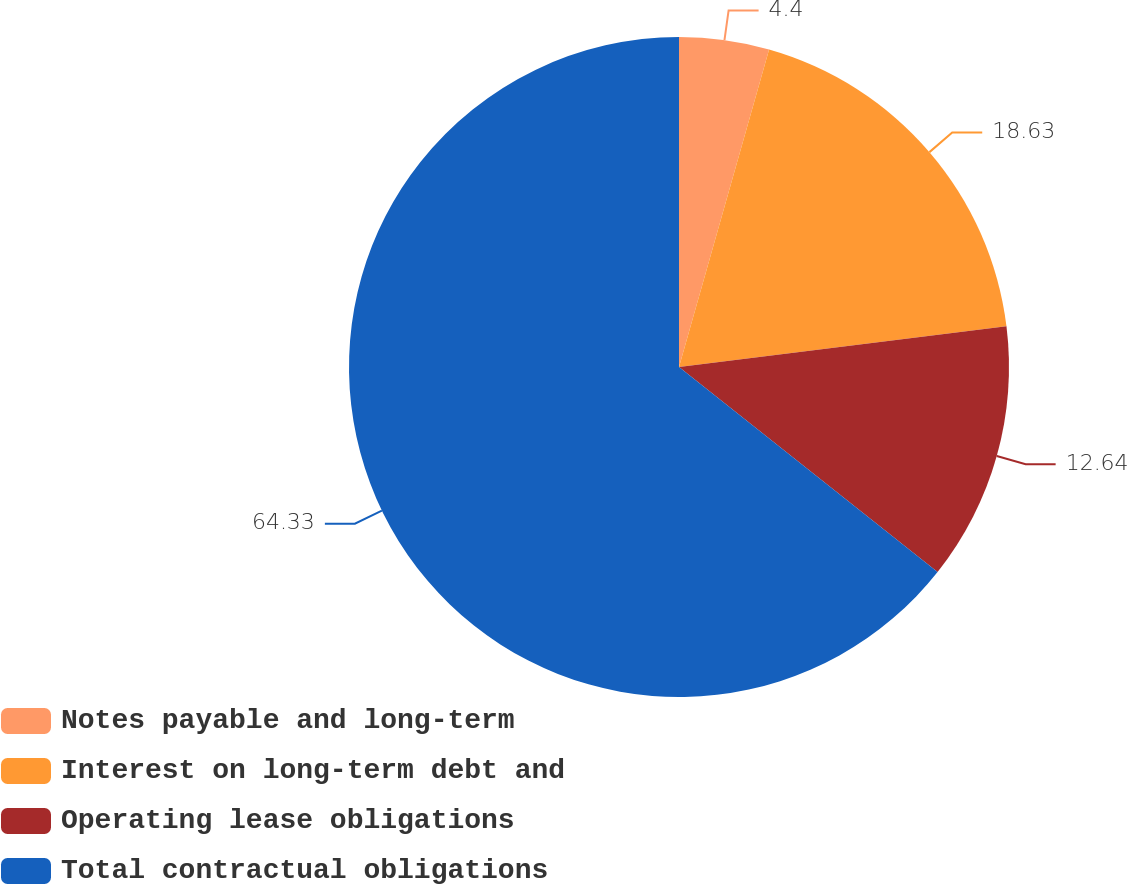<chart> <loc_0><loc_0><loc_500><loc_500><pie_chart><fcel>Notes payable and long-term<fcel>Interest on long-term debt and<fcel>Operating lease obligations<fcel>Total contractual obligations<nl><fcel>4.4%<fcel>18.63%<fcel>12.64%<fcel>64.33%<nl></chart> 